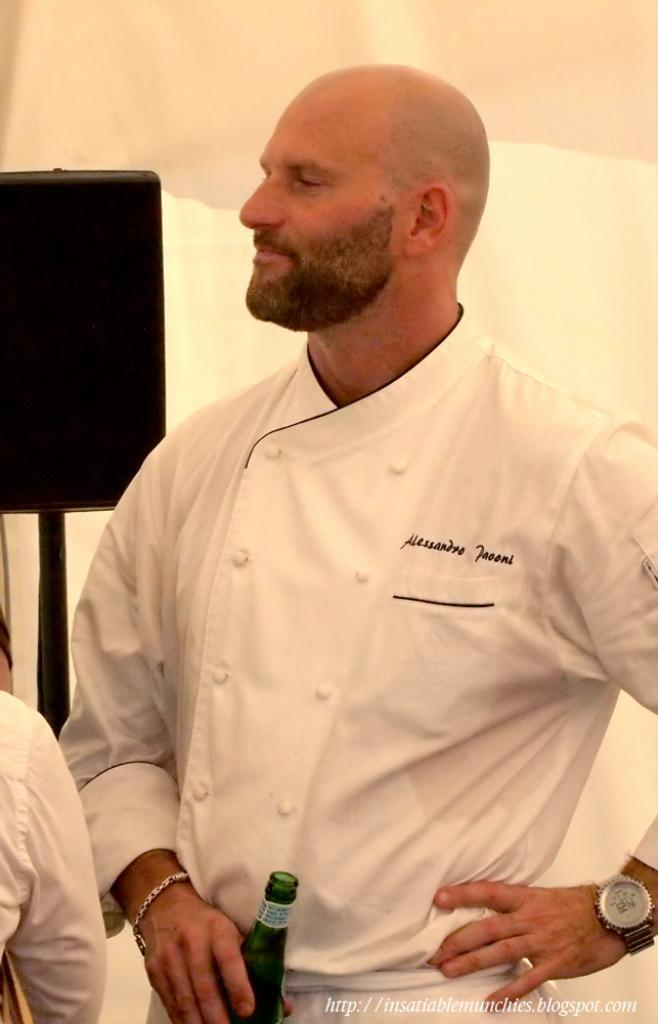<image>
Share a concise interpretation of the image provided. A man in a white chefs shirt named Alessandro Paooni. 